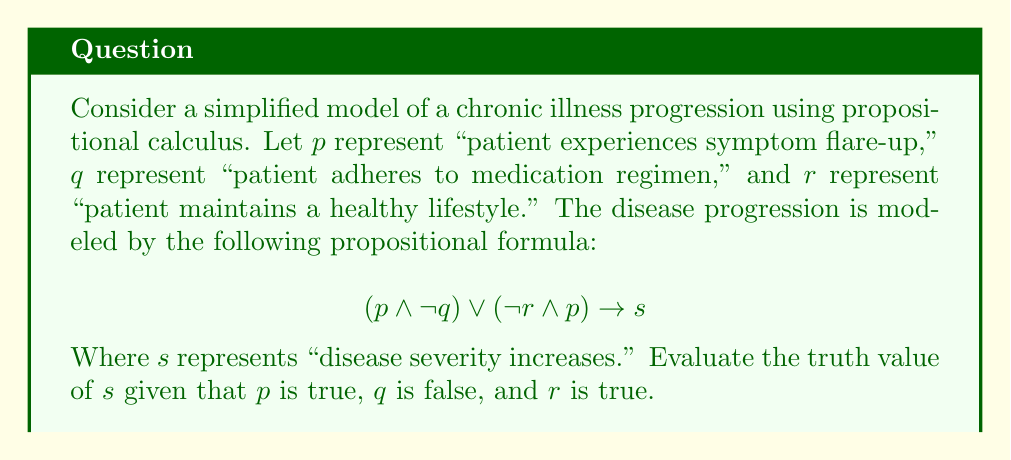Help me with this question. Let's approach this step-by-step:

1) We are given that:
   $p$ is true (T)
   $q$ is false (F)
   $r$ is true (T)

2) Let's evaluate the left side of the implication first: $(p \wedge \neg q) \vee (\neg r \wedge p)$

3) Start with $(p \wedge \neg q)$:
   $p$ is true and $\neg q$ is true (since $q$ is false)
   So, $(p \wedge \neg q)$ is true (T)

4) Now evaluate $(\neg r \wedge p)$:
   $\neg r$ is false (since $r$ is true) and $p$ is true
   So, $(\neg r \wedge p)$ is false (F)

5) Now we have: $T \vee F$
   The disjunction (OR) of true and false is true (T)

6) So, the left side of the implication is true (T)

7) In propositional logic, when the antecedent (left side) of an implication is true, the consequent (right side) must also be true for the implication to be true.

8) Therefore, $s$ must be true for the entire proposition to be true.
Answer: The truth value of $s$ is true (T). 